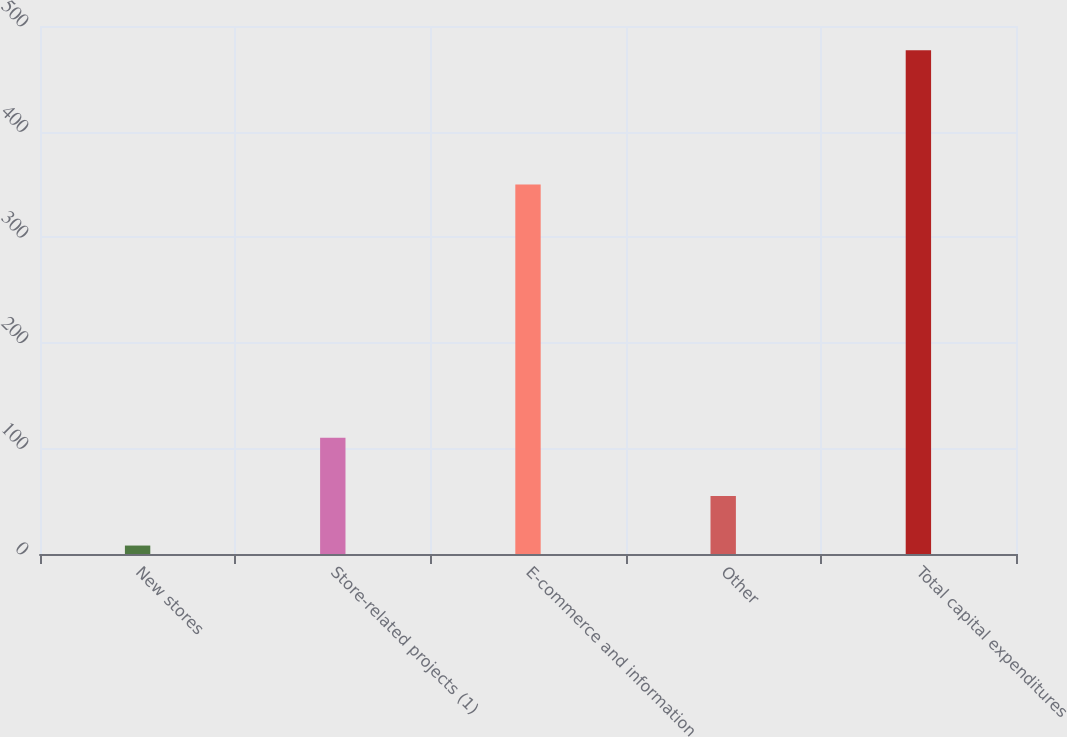Convert chart. <chart><loc_0><loc_0><loc_500><loc_500><bar_chart><fcel>New stores<fcel>Store-related projects (1)<fcel>E-commerce and information<fcel>Other<fcel>Total capital expenditures<nl><fcel>8<fcel>110<fcel>350<fcel>54.9<fcel>477<nl></chart> 